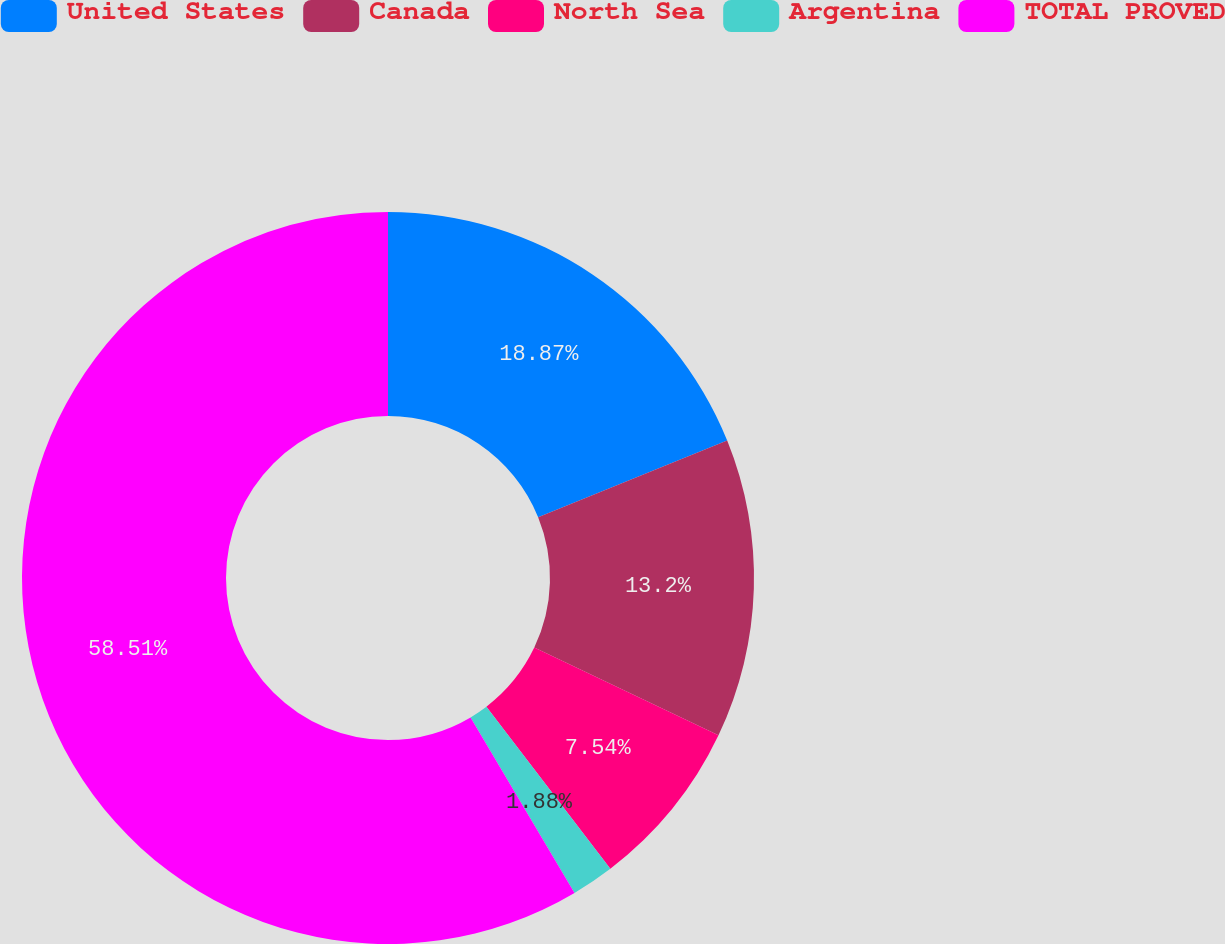Convert chart. <chart><loc_0><loc_0><loc_500><loc_500><pie_chart><fcel>United States<fcel>Canada<fcel>North Sea<fcel>Argentina<fcel>TOTAL PROVED<nl><fcel>18.87%<fcel>13.2%<fcel>7.54%<fcel>1.88%<fcel>58.51%<nl></chart> 